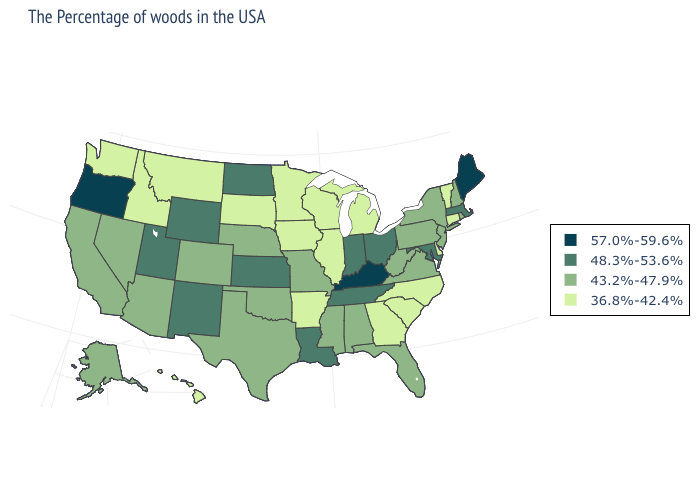Does Indiana have the highest value in the MidWest?
Answer briefly. Yes. What is the lowest value in states that border Virginia?
Write a very short answer. 36.8%-42.4%. Name the states that have a value in the range 57.0%-59.6%?
Quick response, please. Maine, Kentucky, Oregon. Does Vermont have the lowest value in the Northeast?
Write a very short answer. Yes. What is the highest value in the USA?
Answer briefly. 57.0%-59.6%. Which states have the lowest value in the USA?
Concise answer only. Vermont, Connecticut, Delaware, North Carolina, South Carolina, Georgia, Michigan, Wisconsin, Illinois, Arkansas, Minnesota, Iowa, South Dakota, Montana, Idaho, Washington, Hawaii. Does the map have missing data?
Short answer required. No. What is the highest value in the USA?
Short answer required. 57.0%-59.6%. What is the value of Missouri?
Write a very short answer. 43.2%-47.9%. Name the states that have a value in the range 36.8%-42.4%?
Be succinct. Vermont, Connecticut, Delaware, North Carolina, South Carolina, Georgia, Michigan, Wisconsin, Illinois, Arkansas, Minnesota, Iowa, South Dakota, Montana, Idaho, Washington, Hawaii. What is the value of Oregon?
Quick response, please. 57.0%-59.6%. Name the states that have a value in the range 43.2%-47.9%?
Concise answer only. Rhode Island, New Hampshire, New York, New Jersey, Pennsylvania, Virginia, West Virginia, Florida, Alabama, Mississippi, Missouri, Nebraska, Oklahoma, Texas, Colorado, Arizona, Nevada, California, Alaska. Does North Dakota have the highest value in the USA?
Give a very brief answer. No. What is the value of Illinois?
Short answer required. 36.8%-42.4%. What is the value of Mississippi?
Write a very short answer. 43.2%-47.9%. 